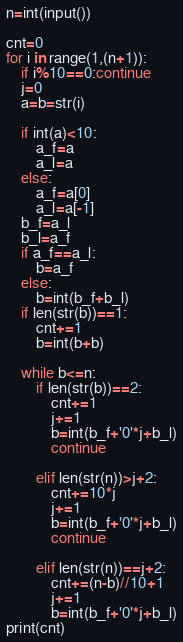<code> <loc_0><loc_0><loc_500><loc_500><_Python_>n=int(input())

cnt=0
for i in range(1,(n+1)):
    if i%10==0:continue
    j=0
    a=b=str(i)

    if int(a)<10:
        a_f=a
        a_l=a
    else:
        a_f=a[0]
        a_l=a[-1]
    b_f=a_l
    b_l=a_f
    if a_f==a_l:
        b=a_f
    else:
        b=int(b_f+b_l)
    if len(str(b))==1:
        cnt+=1
        b=int(b+b)
    
    while b<=n:
        if len(str(b))==2:
            cnt+=1
            j+=1
            b=int(b_f+'0'*j+b_l)
            continue

        elif len(str(n))>j+2:
            cnt+=10*j
            j+=1
            b=int(b_f+'0'*j+b_l)
            continue

        elif len(str(n))==j+2:
            cnt+=(n-b)//10+1
            j+=1
            b=int(b_f+'0'*j+b_l)
print(cnt)        </code> 